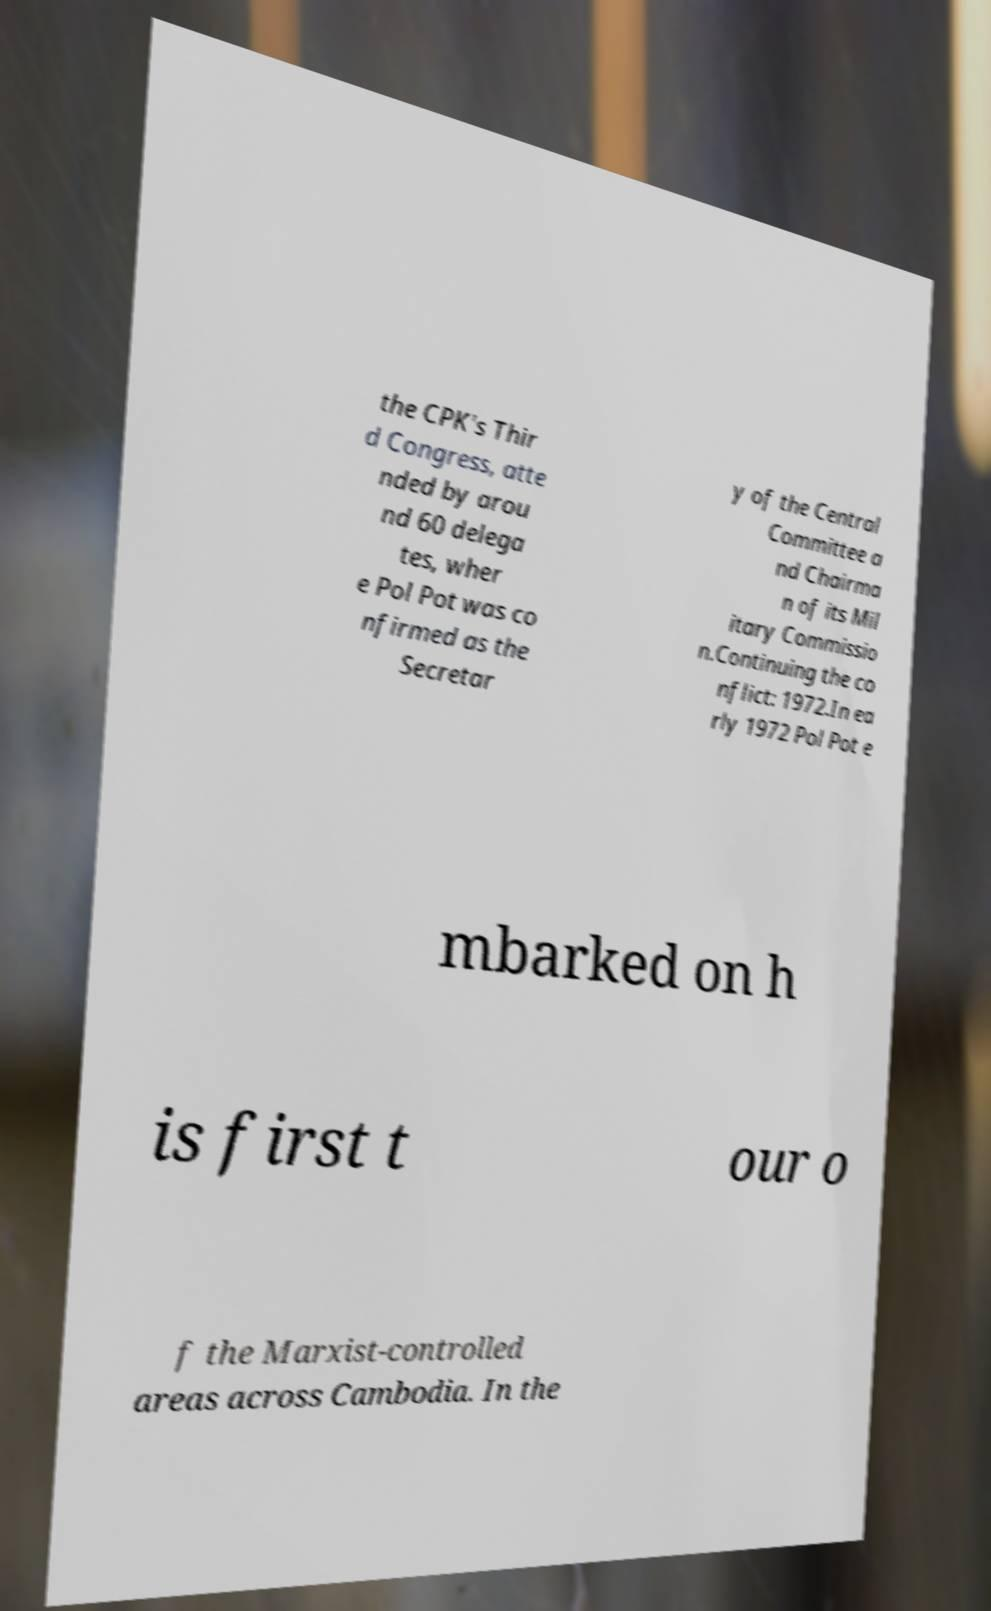Please read and relay the text visible in this image. What does it say? the CPK's Thir d Congress, atte nded by arou nd 60 delega tes, wher e Pol Pot was co nfirmed as the Secretar y of the Central Committee a nd Chairma n of its Mil itary Commissio n.Continuing the co nflict: 1972.In ea rly 1972 Pol Pot e mbarked on h is first t our o f the Marxist-controlled areas across Cambodia. In the 